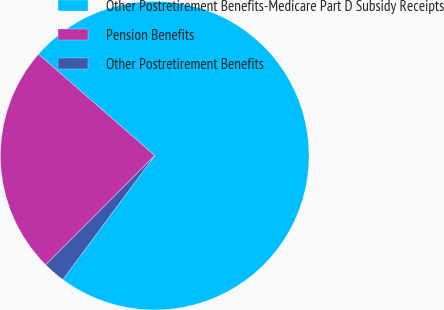Convert chart. <chart><loc_0><loc_0><loc_500><loc_500><pie_chart><fcel>Other Postretirement Benefits-Medicare Part D Subsidy Receipts<fcel>Pension Benefits<fcel>Other Postretirement Benefits<nl><fcel>73.73%<fcel>23.93%<fcel>2.34%<nl></chart> 